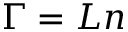<formula> <loc_0><loc_0><loc_500><loc_500>\Gamma = L n</formula> 